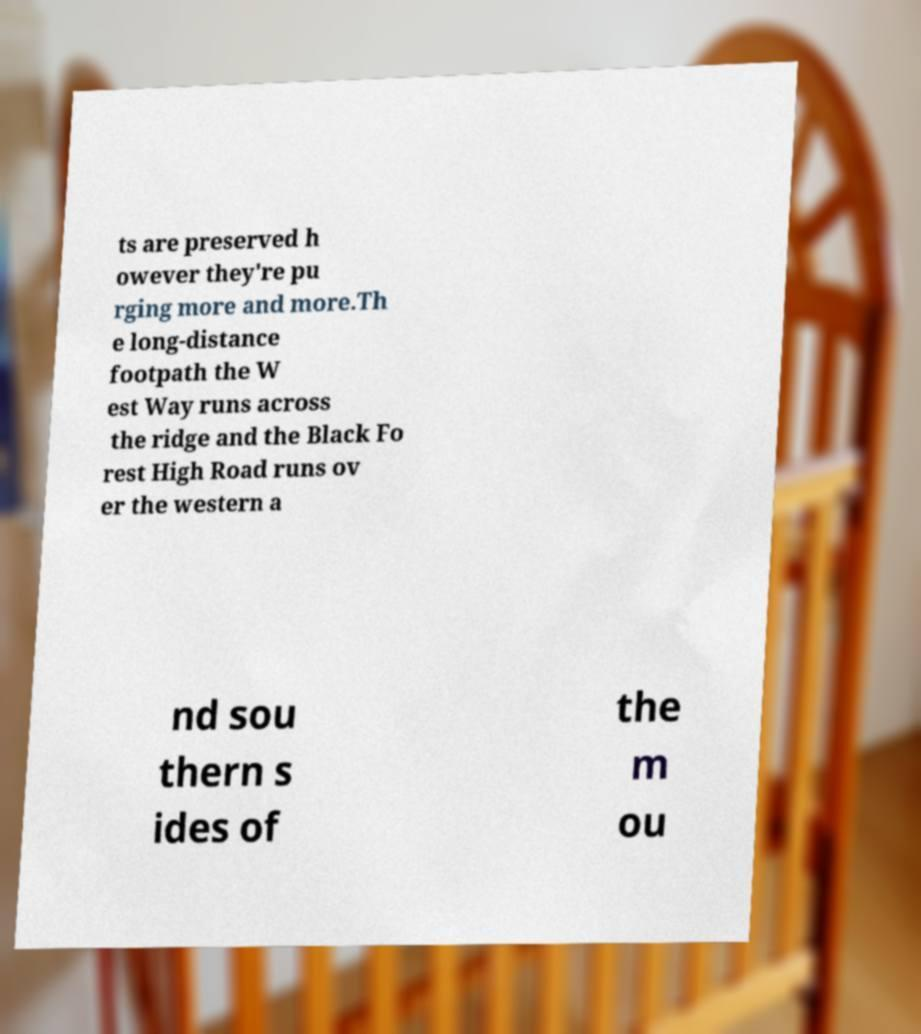Can you accurately transcribe the text from the provided image for me? ts are preserved h owever they're pu rging more and more.Th e long-distance footpath the W est Way runs across the ridge and the Black Fo rest High Road runs ov er the western a nd sou thern s ides of the m ou 